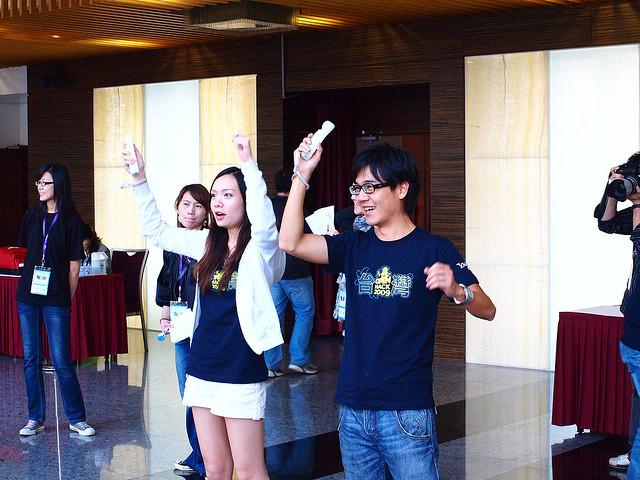What color shirt does the girl have on in the background?
Concise answer only. Black. Where is the person with camera?
Quick response, please. Back. Are there flowers on the guy's clothes?
Answer briefly. No. What is happening in the picture?
Write a very short answer. Playing wii. What color is the girl's jacket?
Concise answer only. White. What game system are the people playing with?
Quick response, please. Wii. 